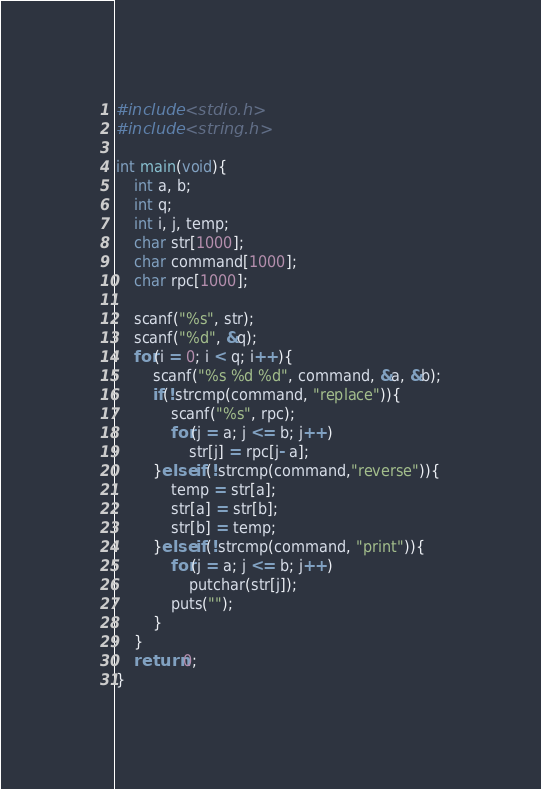Convert code to text. <code><loc_0><loc_0><loc_500><loc_500><_C_>#include <stdio.h>
#include <string.h>

int main(void){
    int a, b;
    int q;
    int i, j, temp;
    char str[1000];
    char command[1000];
    char rpc[1000];

    scanf("%s", str);
    scanf("%d", &q);
    for(i = 0; i < q; i++){
        scanf("%s %d %d", command, &a, &b);
        if(!strcmp(command, "replace")){
            scanf("%s", rpc);
            for(j = a; j <= b; j++)
                str[j] = rpc[j- a];
        }else if(!strcmp(command,"reverse")){
            temp = str[a];
            str[a] = str[b];
            str[b] = temp;
        }else if(!strcmp(command, "print")){
            for(j = a; j <= b; j++)
                putchar(str[j]);
            puts("");
        }
    }
    return 0;
}

</code> 